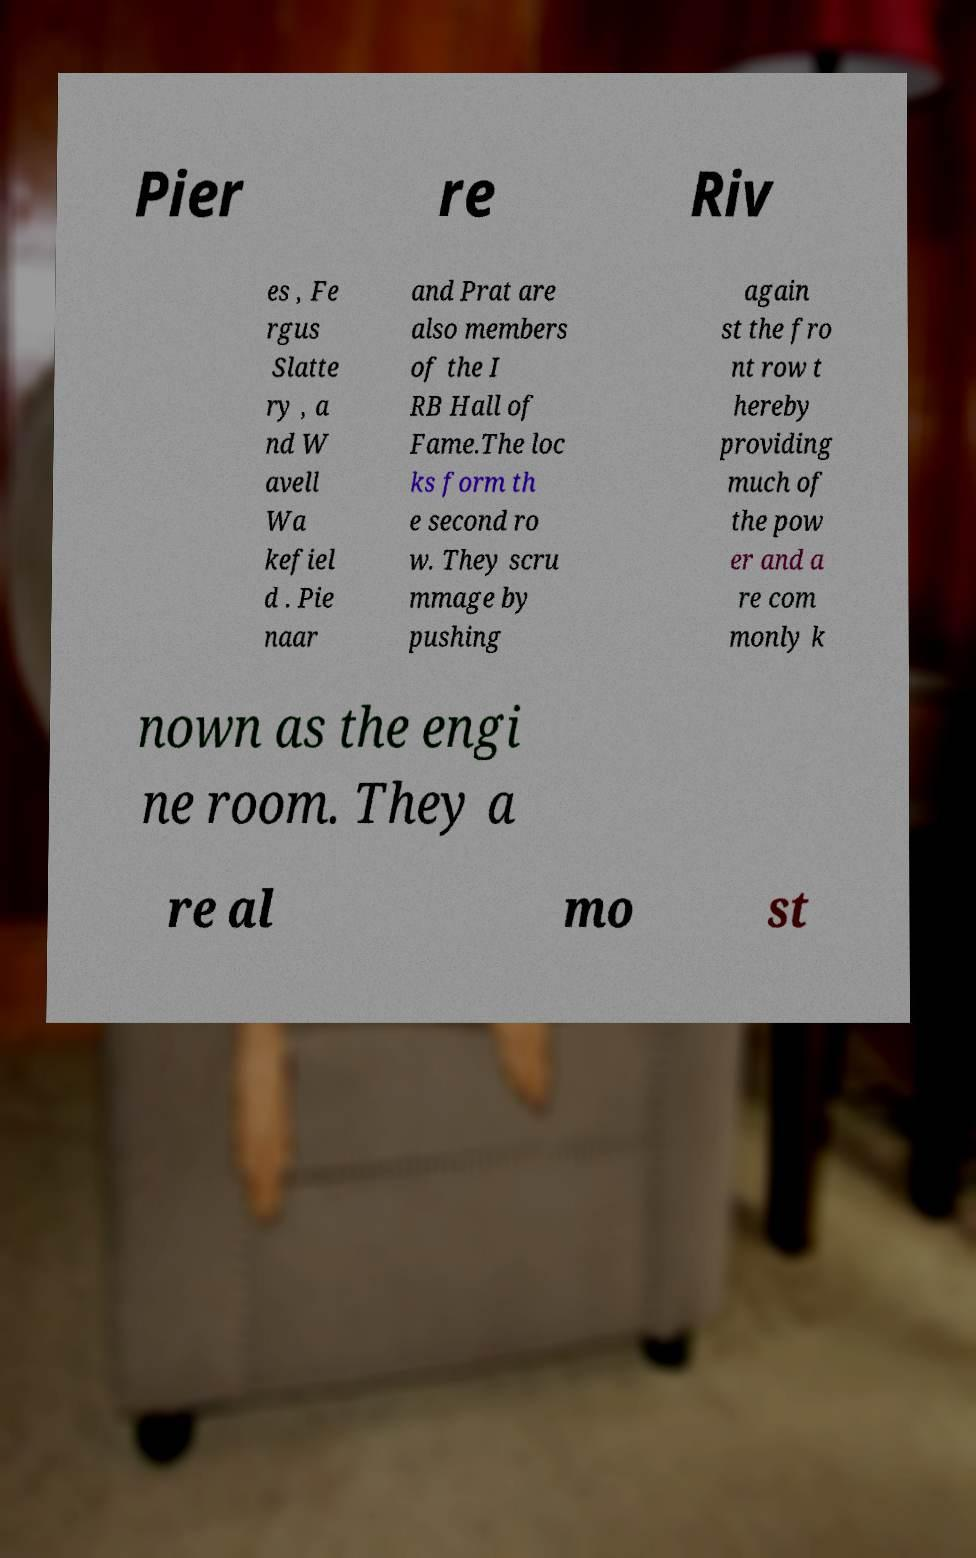Please identify and transcribe the text found in this image. Pier re Riv es , Fe rgus Slatte ry , a nd W avell Wa kefiel d . Pie naar and Prat are also members of the I RB Hall of Fame.The loc ks form th e second ro w. They scru mmage by pushing again st the fro nt row t hereby providing much of the pow er and a re com monly k nown as the engi ne room. They a re al mo st 